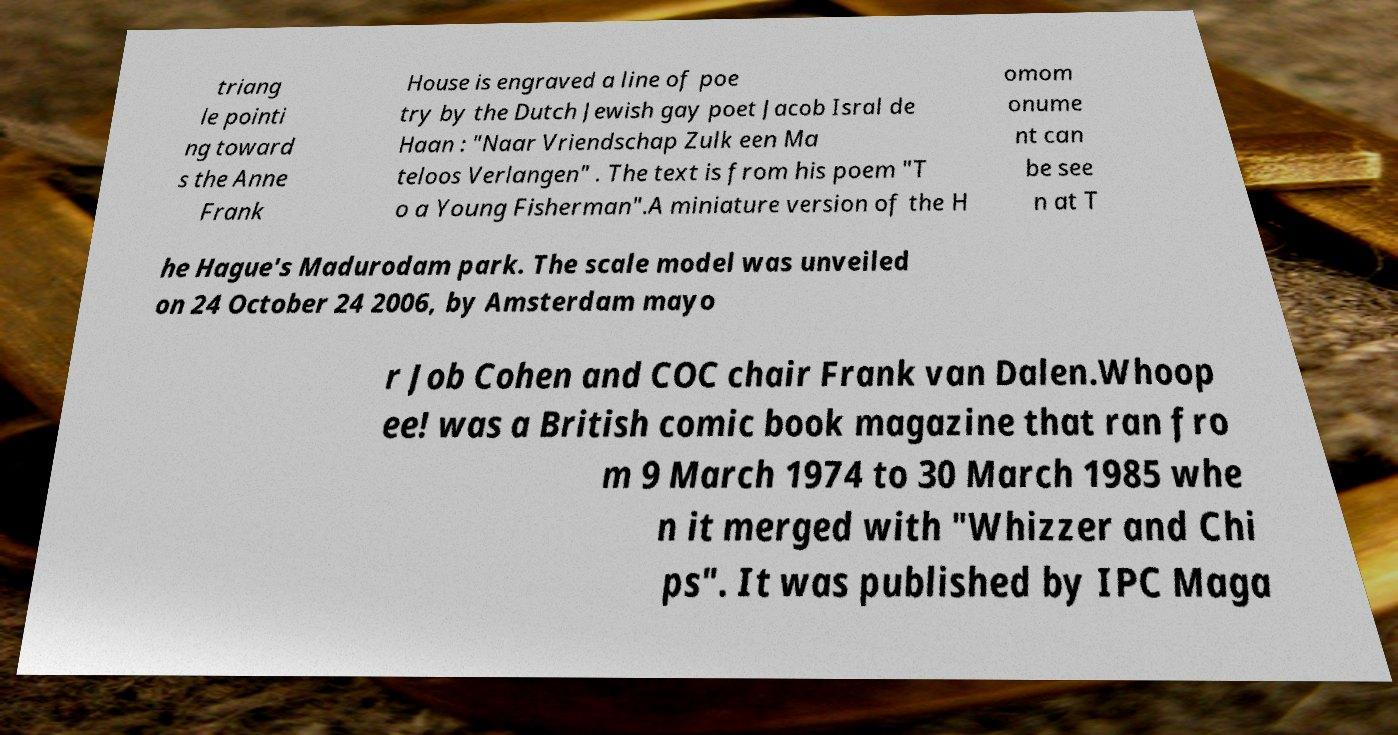Can you accurately transcribe the text from the provided image for me? triang le pointi ng toward s the Anne Frank House is engraved a line of poe try by the Dutch Jewish gay poet Jacob Isral de Haan : "Naar Vriendschap Zulk een Ma teloos Verlangen" . The text is from his poem "T o a Young Fisherman".A miniature version of the H omom onume nt can be see n at T he Hague's Madurodam park. The scale model was unveiled on 24 October 24 2006, by Amsterdam mayo r Job Cohen and COC chair Frank van Dalen.Whoop ee! was a British comic book magazine that ran fro m 9 March 1974 to 30 March 1985 whe n it merged with "Whizzer and Chi ps". It was published by IPC Maga 